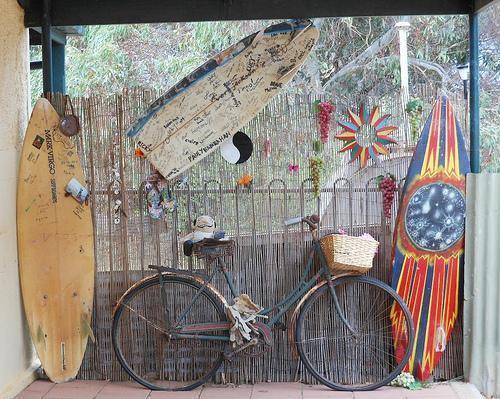How many bikes are in the picture?
Give a very brief answer. 1. How many surfboards are painted vividly?
Give a very brief answer. 1. 